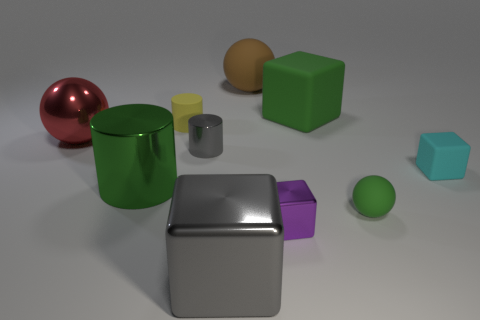Subtract all cylinders. How many objects are left? 7 Add 1 big gray metal blocks. How many big gray metal blocks exist? 2 Subtract 0 blue cubes. How many objects are left? 10 Subtract all big brown cylinders. Subtract all metallic things. How many objects are left? 5 Add 8 green rubber blocks. How many green rubber blocks are left? 9 